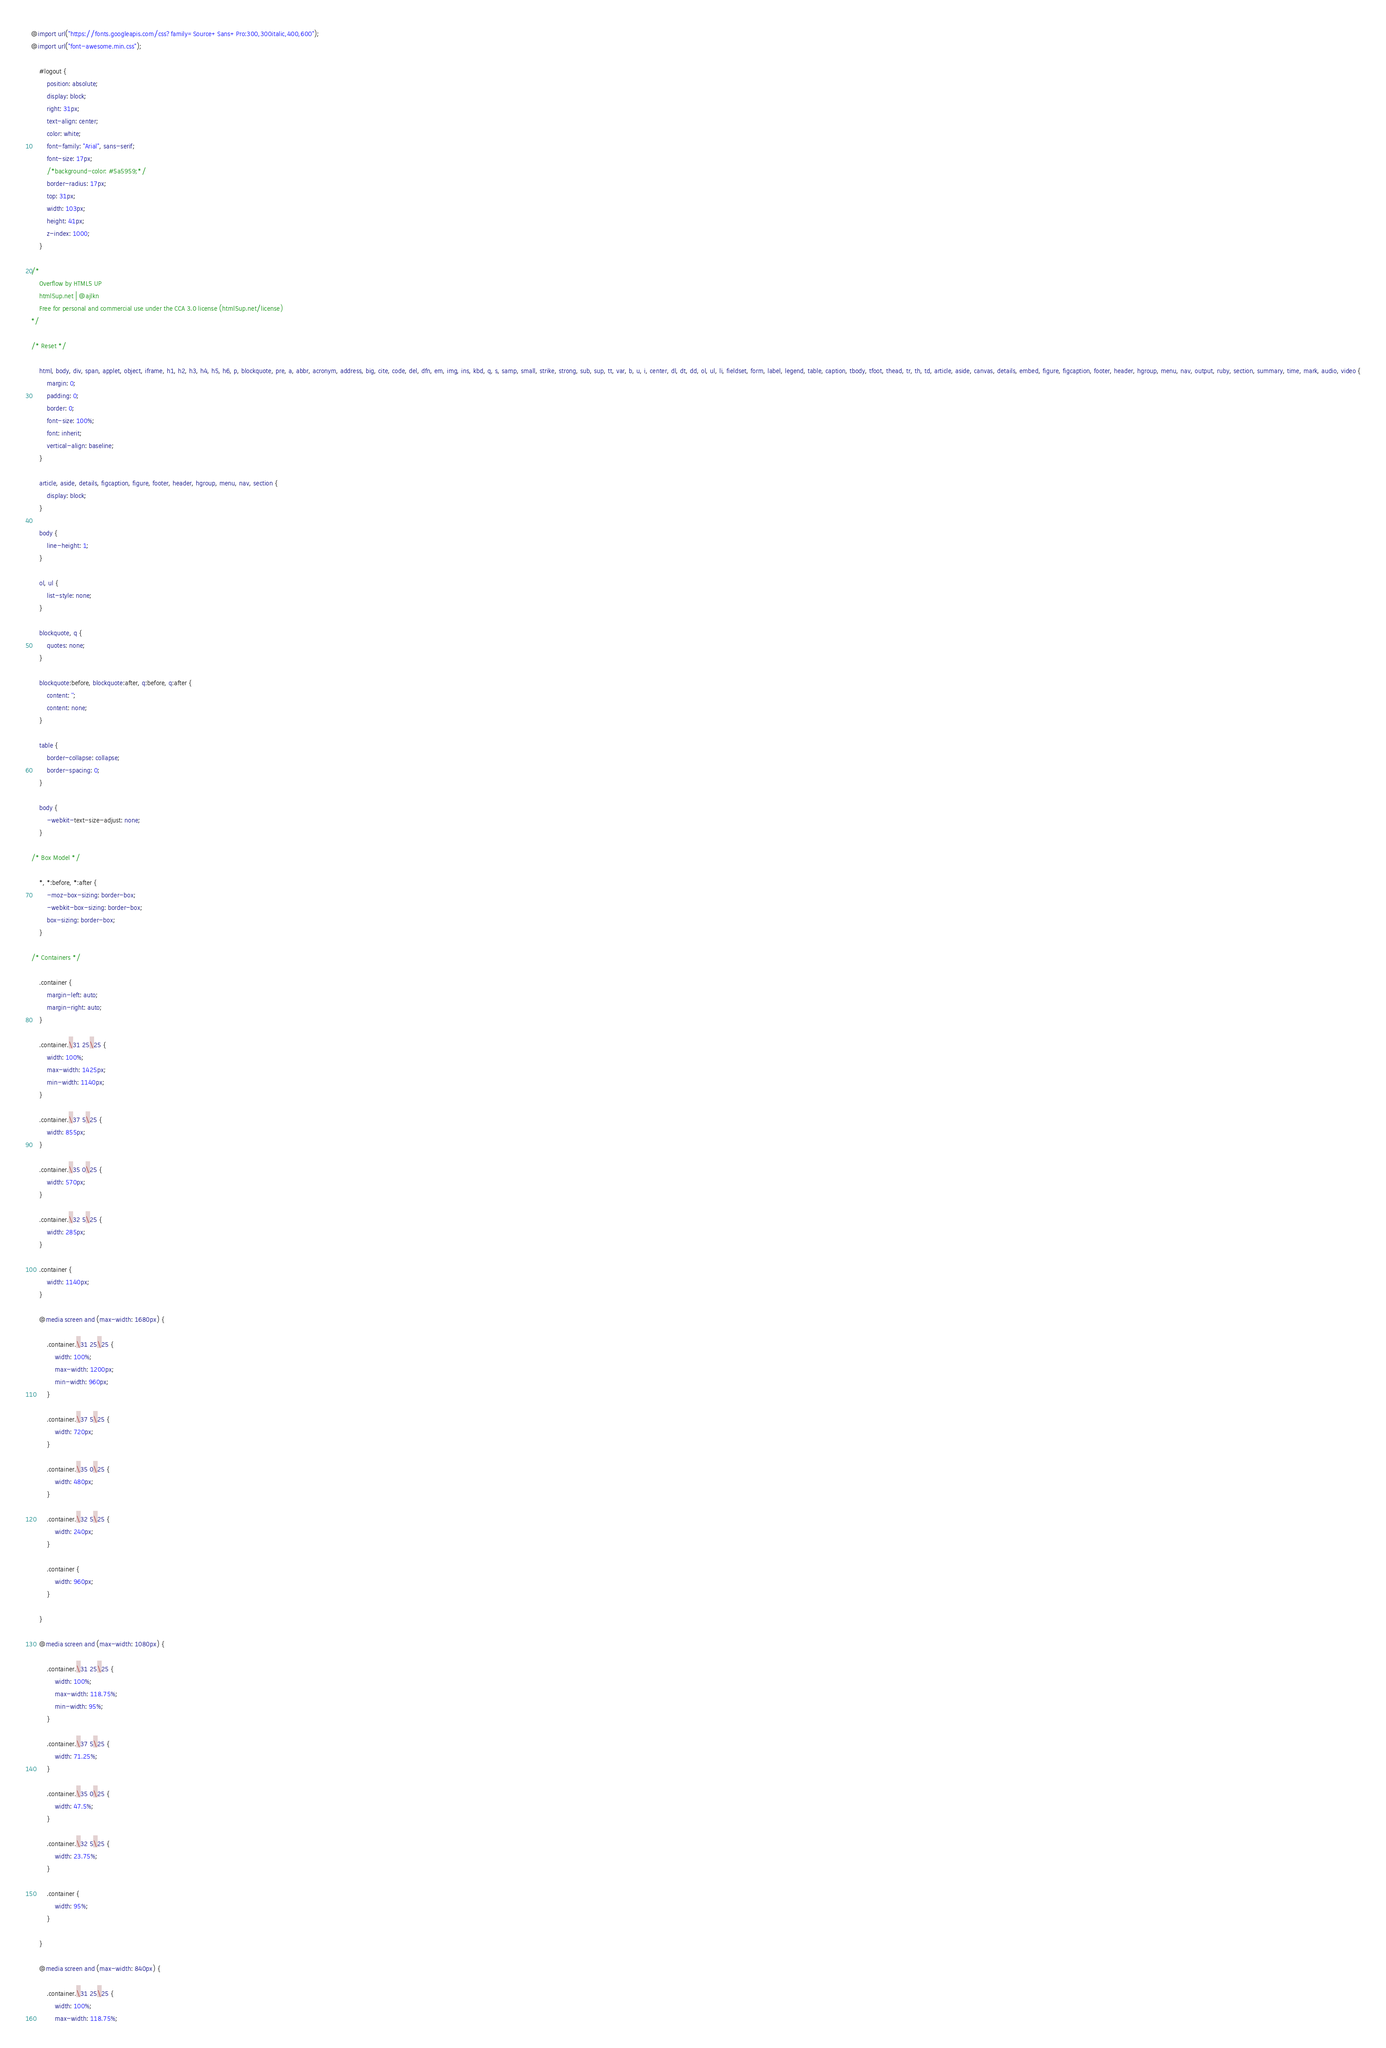Convert code to text. <code><loc_0><loc_0><loc_500><loc_500><_CSS_>@import url("https://fonts.googleapis.com/css?family=Source+Sans+Pro:300,300italic,400,600");
@import url("font-awesome.min.css");

	#logout {
		position: absolute;
		display: block;
		right: 31px;
		text-align: center;
		color: white;
		font-family: "Arial", sans-serif;
		font-size: 17px;
		/*background-color: #5a5959;*/
		border-radius: 17px;
		top: 31px;
		width: 103px;
		height: 41px;
		z-index: 1000;
	}

/*
	Overflow by HTML5 UP
	html5up.net | @ajlkn
	Free for personal and commercial use under the CCA 3.0 license (html5up.net/license)
*/

/* Reset */

	html, body, div, span, applet, object, iframe, h1, h2, h3, h4, h5, h6, p, blockquote, pre, a, abbr, acronym, address, big, cite, code, del, dfn, em, img, ins, kbd, q, s, samp, small, strike, strong, sub, sup, tt, var, b, u, i, center, dl, dt, dd, ol, ul, li, fieldset, form, label, legend, table, caption, tbody, tfoot, thead, tr, th, td, article, aside, canvas, details, embed, figure, figcaption, footer, header, hgroup, menu, nav, output, ruby, section, summary, time, mark, audio, video {
		margin: 0;
		padding: 0;
		border: 0;
		font-size: 100%;
		font: inherit;
		vertical-align: baseline;
	}

	article, aside, details, figcaption, figure, footer, header, hgroup, menu, nav, section {
		display: block;
	}

	body {
		line-height: 1;
	}

	ol, ul {
		list-style: none;
	}

	blockquote, q {
		quotes: none;
	}

	blockquote:before, blockquote:after, q:before, q:after {
		content: '';
		content: none;
	}

	table {
		border-collapse: collapse;
		border-spacing: 0;
	}

	body {
		-webkit-text-size-adjust: none;
	}

/* Box Model */

	*, *:before, *:after {
		-moz-box-sizing: border-box;
		-webkit-box-sizing: border-box;
		box-sizing: border-box;
	}

/* Containers */

	.container {
		margin-left: auto;
		margin-right: auto;
	}

	.container.\31 25\25 {
		width: 100%;
		max-width: 1425px;
		min-width: 1140px;
	}

	.container.\37 5\25 {
		width: 855px;
	}

	.container.\35 0\25 {
		width: 570px;
	}

	.container.\32 5\25 {
		width: 285px;
	}

	.container {
		width: 1140px;
	}

	@media screen and (max-width: 1680px) {

		.container.\31 25\25 {
			width: 100%;
			max-width: 1200px;
			min-width: 960px;
		}

		.container.\37 5\25 {
			width: 720px;
		}

		.container.\35 0\25 {
			width: 480px;
		}

		.container.\32 5\25 {
			width: 240px;
		}

		.container {
			width: 960px;
		}

	}

	@media screen and (max-width: 1080px) {

		.container.\31 25\25 {
			width: 100%;
			max-width: 118.75%;
			min-width: 95%;
		}

		.container.\37 5\25 {
			width: 71.25%;
		}

		.container.\35 0\25 {
			width: 47.5%;
		}

		.container.\32 5\25 {
			width: 23.75%;
		}

		.container {
			width: 95%;
		}

	}

	@media screen and (max-width: 840px) {

		.container.\31 25\25 {
			width: 100%;
			max-width: 118.75%;</code> 